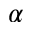<formula> <loc_0><loc_0><loc_500><loc_500>\alpha</formula> 